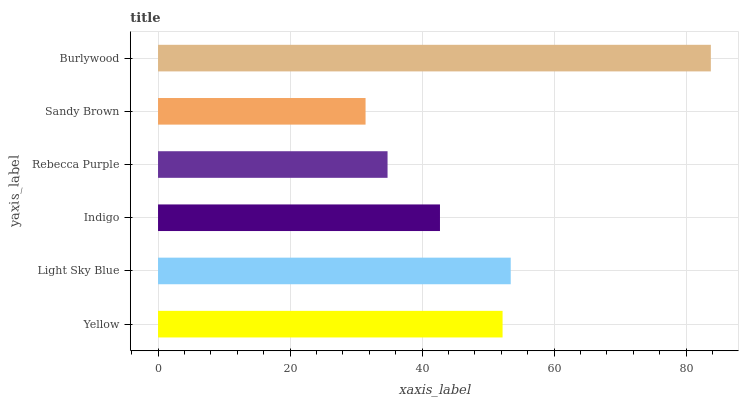Is Sandy Brown the minimum?
Answer yes or no. Yes. Is Burlywood the maximum?
Answer yes or no. Yes. Is Light Sky Blue the minimum?
Answer yes or no. No. Is Light Sky Blue the maximum?
Answer yes or no. No. Is Light Sky Blue greater than Yellow?
Answer yes or no. Yes. Is Yellow less than Light Sky Blue?
Answer yes or no. Yes. Is Yellow greater than Light Sky Blue?
Answer yes or no. No. Is Light Sky Blue less than Yellow?
Answer yes or no. No. Is Yellow the high median?
Answer yes or no. Yes. Is Indigo the low median?
Answer yes or no. Yes. Is Burlywood the high median?
Answer yes or no. No. Is Yellow the low median?
Answer yes or no. No. 